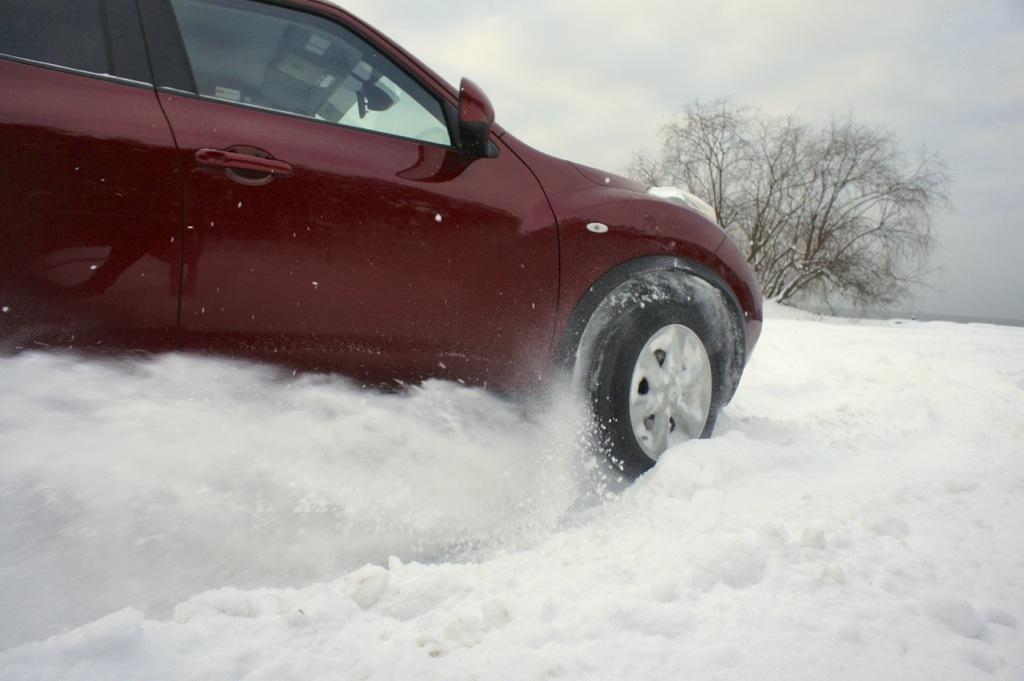How would you summarize this image in a sentence or two? In this image we can see a car on the land covered with snow. In the background, we can see a tree and the sky. 